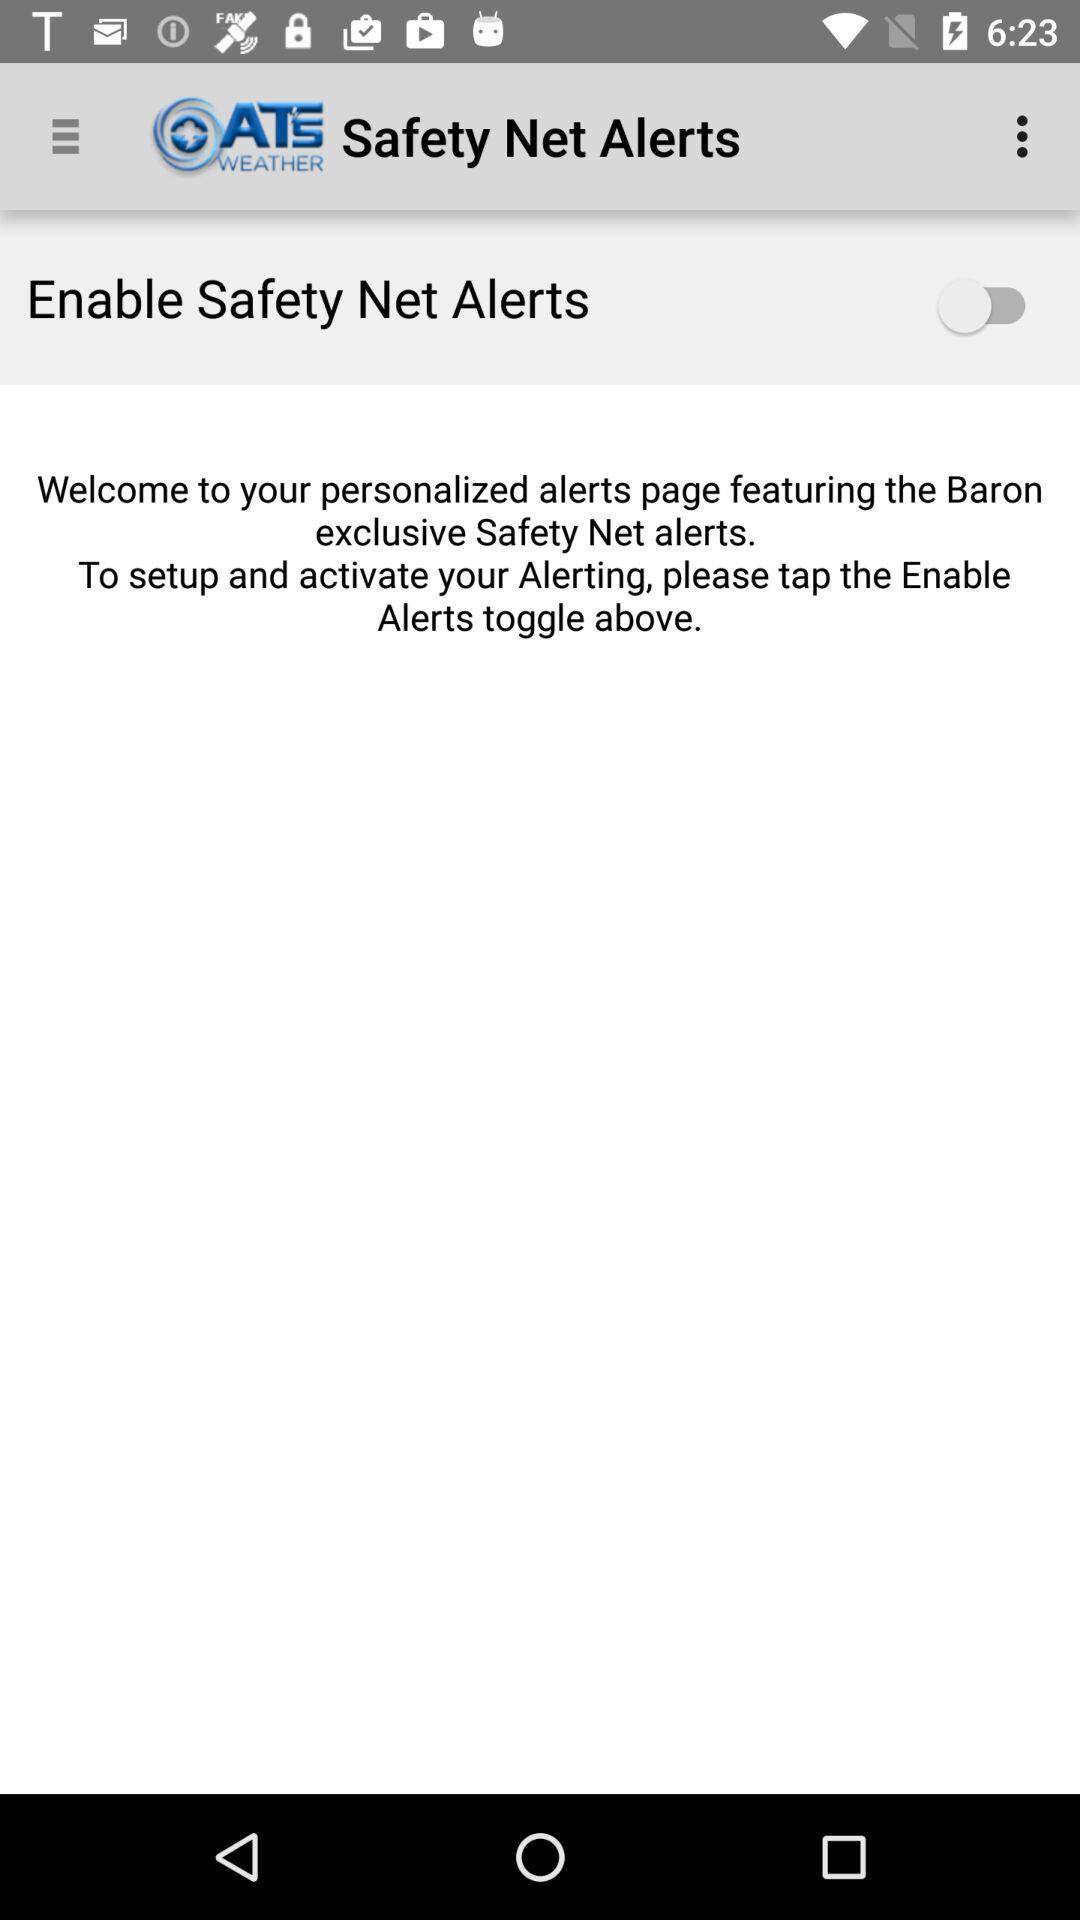What is the status of "Enable Safety Net Alerts"? The status is "off". 